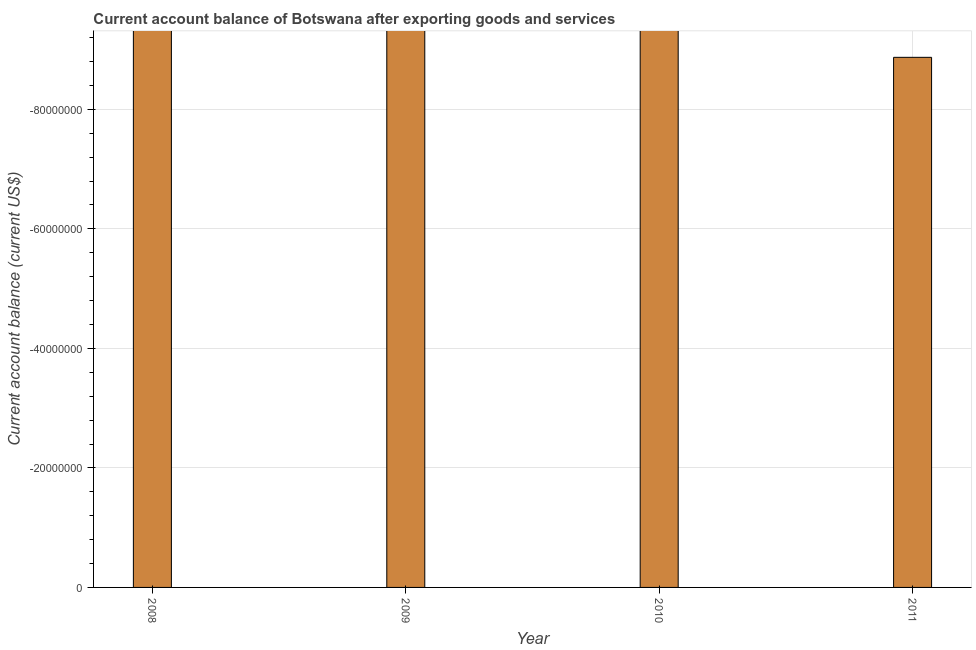What is the title of the graph?
Your answer should be very brief. Current account balance of Botswana after exporting goods and services. What is the label or title of the Y-axis?
Your answer should be compact. Current account balance (current US$). What is the current account balance in 2009?
Ensure brevity in your answer.  0. Across all years, what is the minimum current account balance?
Keep it short and to the point. 0. What is the average current account balance per year?
Give a very brief answer. 0. What is the median current account balance?
Give a very brief answer. 0. How many bars are there?
Keep it short and to the point. 0. How many years are there in the graph?
Keep it short and to the point. 4. What is the difference between two consecutive major ticks on the Y-axis?
Offer a very short reply. 2.00e+07. Are the values on the major ticks of Y-axis written in scientific E-notation?
Your answer should be very brief. No. What is the Current account balance (current US$) in 2008?
Provide a succinct answer. 0. 